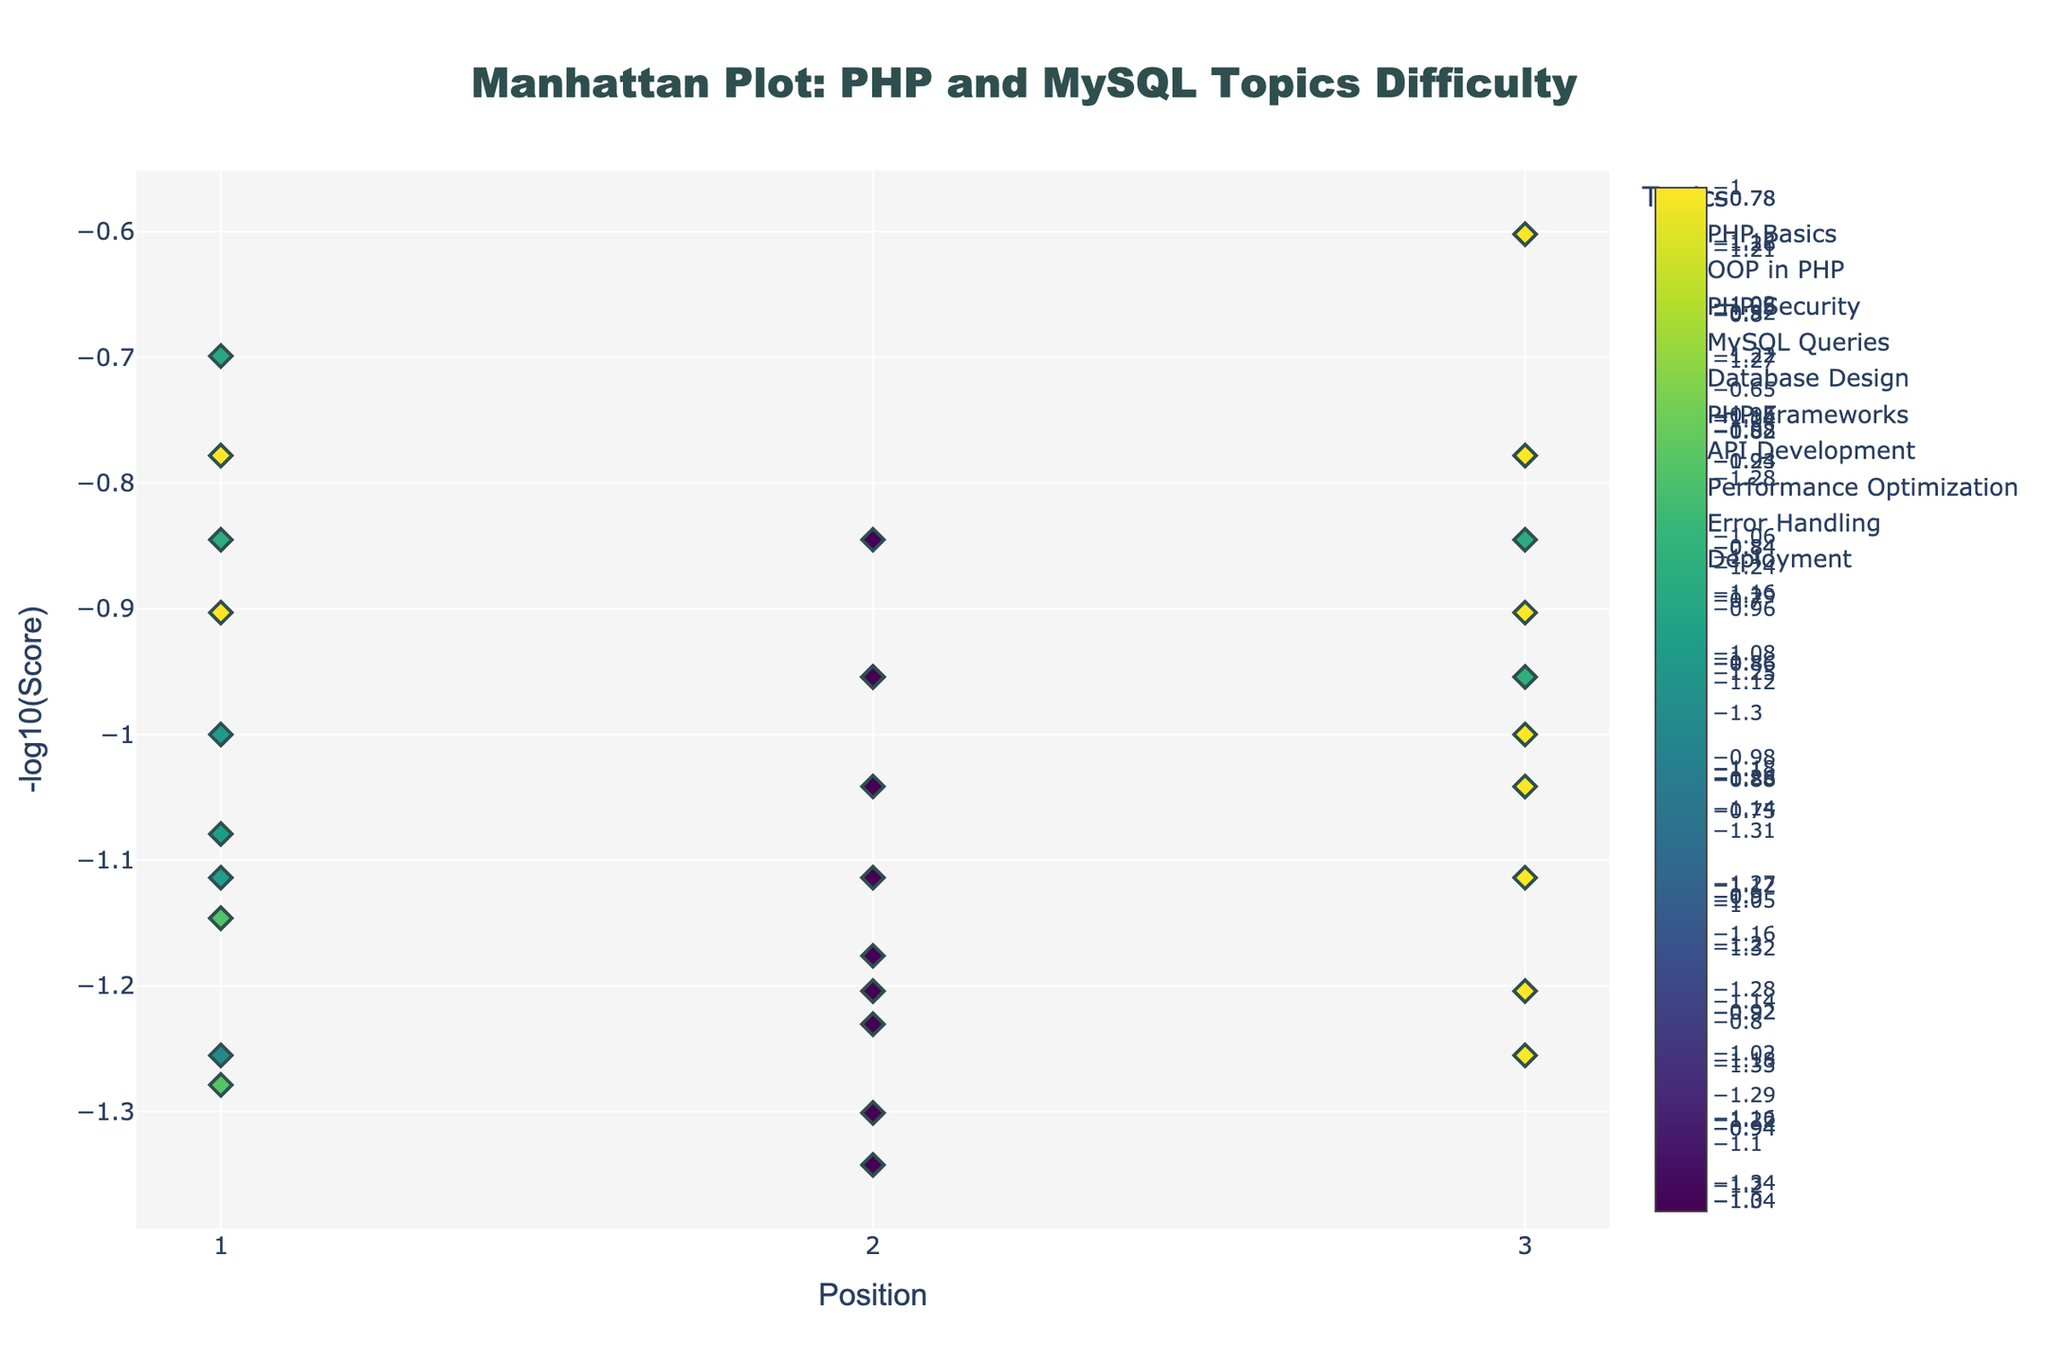What is the title of the plot? The title of the plot is prominently displayed at the top center of the figure. It summarizes the nature of the plot, giving an overview of the data presented.
Answer: Manhattan Plot: PHP and MySQL Topics Difficulty How is the y-axis labeled and what does it represent? The y-axis is labeled "-log10(Score)" and represents the negative logarithm of the scores for each topic position. This transformation helps in visualizing a wide range of values and improves comparative analysis.
Answer: -log10(Score) Which topic has the highest difficulty indicated by the highest -log10(Score) value? The highest difficulty is indicated by the tallest peak on the y-axis. By looking at the values on the y-axis and checking the topic corresponding to that value, you can determine the highest value. The topic with the value closest to `22` is "Performance Optimization".
Answer: Performance Optimization Compare the difficulty levels of "PHP Security" and "Database Design" at their highest values. Which is more challenging? To compare the highest values, find the tallest peak for both "PHP Security" and "Database Design". "PHP Security" reaches around `20` while "Database Design" peaks at `17`.
Answer: PHP Security What is the average -log10(Score) for "MySQL Queries"? Calculate the -log10(Score) values for the scores `8`, `11`, and `9`. Sum these up and divide by the number of positions. `-log10(8) = 0.903, -log10(11) = 1.041, -log10(9) = 0.954`, thus `(0.903 + 1.041 + 0.954) / 3 ≈ 0.966`.
Answer: 0.966 Identify the two topics with the least challenging areas and compare their highest peaks. Find the two smallest peaks among all topics. "PHP Basics" and "Deployment" have the smallest maximum peaks. Compare their highest values and you will find that both have a peak close to `0.903`.
Answer: PHP Basics and Deployment In terms of positioning, which topics have scores that consistently increase with each position? To determine this, observe the markers for each topic. Topics like "Performance Optimization" and "PHP Security" show a trend where the y-values increase with each position `1, 2, 3`.
Answer: Performance Optimization and PHP Security Based on the visual scaling of the plot, which topic shows the most significant variance in difficulty across its three positions? Look for the topic where the peak heights vary drastically from position to position. "Error Handling" has peaks at `10`, `13`, and `8`, showing a noticeable variance visually.
Answer: Error Handling 